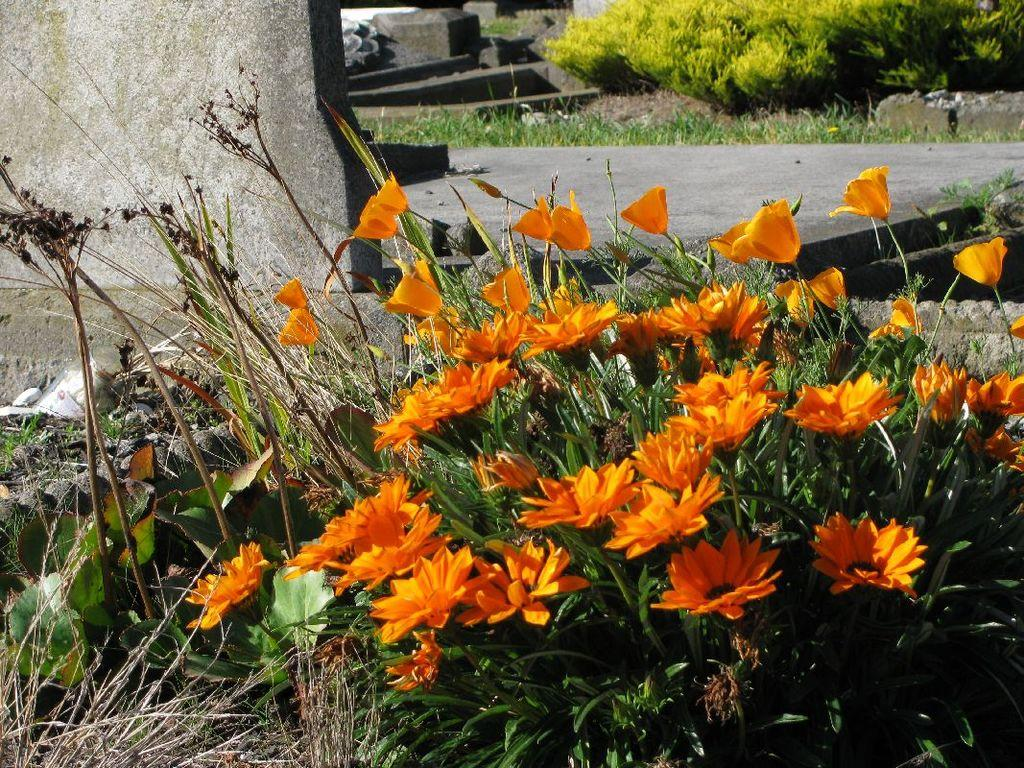What type of plants are in the image? There are grass plants with orange color flowers in the image. What structure can be seen in the image? There is a part of a wall visible in the image. What is the surface visible in the image used for? The purpose of the surface visible in the image is not specified, but it could be a path or a patio. What can be seen in the background of the image? Grass is present in the background of the image. What type of jam is being spread on the scarecrow in the image? There is no jam or scarecrow present in the image; it features grass plants with orange flowers and a part of a wall. 